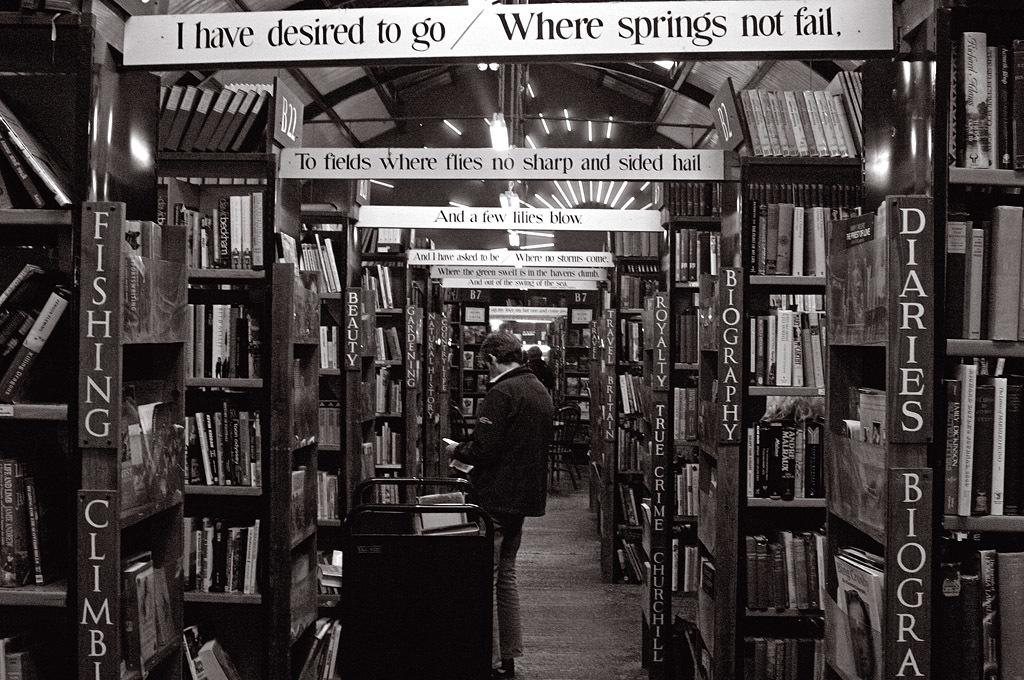Provide a one-sentence caption for the provided image. A library with a banner that says I have desired to go where springs not fail. 